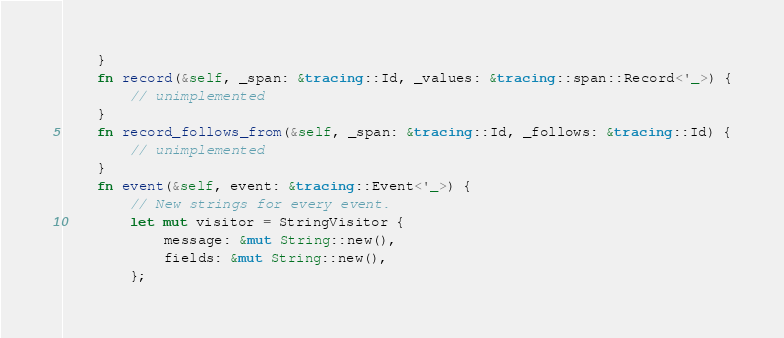Convert code to text. <code><loc_0><loc_0><loc_500><loc_500><_Rust_>    }
    fn record(&self, _span: &tracing::Id, _values: &tracing::span::Record<'_>) {
        // unimplemented
    }
    fn record_follows_from(&self, _span: &tracing::Id, _follows: &tracing::Id) {
        // unimplemented
    }
    fn event(&self, event: &tracing::Event<'_>) {
        // New strings for every event.
        let mut visitor = StringVisitor {
            message: &mut String::new(),
            fields: &mut String::new(),
        };
</code> 